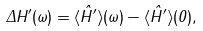<formula> <loc_0><loc_0><loc_500><loc_500>\Delta H ^ { \prime } ( \omega ) = \langle \hat { H } ^ { \prime } \rangle ( \omega ) - \langle \hat { H } ^ { \prime } \rangle ( 0 ) ,</formula> 